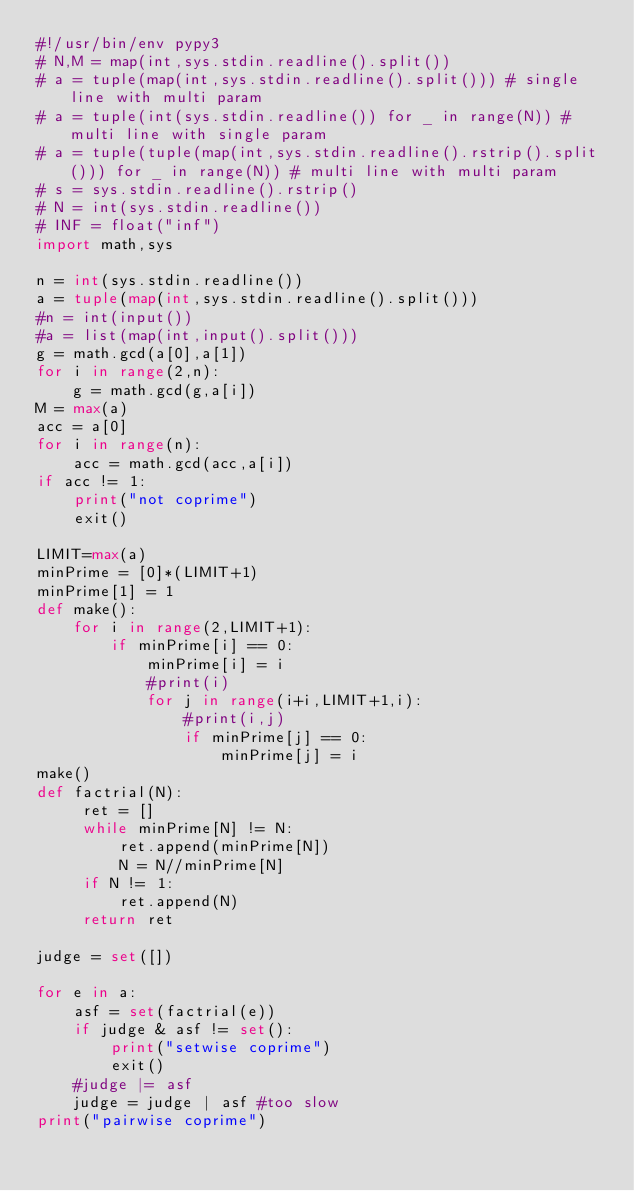<code> <loc_0><loc_0><loc_500><loc_500><_Python_>#!/usr/bin/env pypy3
# N,M = map(int,sys.stdin.readline().split())
# a = tuple(map(int,sys.stdin.readline().split())) # single line with multi param
# a = tuple(int(sys.stdin.readline()) for _ in range(N)) # multi line with single param
# a = tuple(tuple(map(int,sys.stdin.readline().rstrip().split())) for _ in range(N)) # multi line with multi param
# s = sys.stdin.readline().rstrip()
# N = int(sys.stdin.readline())
# INF = float("inf")
import math,sys

n = int(sys.stdin.readline())
a = tuple(map(int,sys.stdin.readline().split()))
#n = int(input())
#a = list(map(int,input().split()))
g = math.gcd(a[0],a[1])
for i in range(2,n):
    g = math.gcd(g,a[i])
M = max(a)
acc = a[0]
for i in range(n):
    acc = math.gcd(acc,a[i])
if acc != 1:
    print("not coprime")
    exit()

LIMIT=max(a)
minPrime = [0]*(LIMIT+1)
minPrime[1] = 1
def make():
    for i in range(2,LIMIT+1):
        if minPrime[i] == 0:
            minPrime[i] = i
            #print(i)
            for j in range(i+i,LIMIT+1,i):
                #print(i,j)
                if minPrime[j] == 0:
                    minPrime[j] = i
make()
def factrial(N):
     ret = []
     while minPrime[N] != N:
         ret.append(minPrime[N])
         N = N//minPrime[N]
     if N != 1:
         ret.append(N)
     return ret

judge = set([])

for e in a:
    asf = set(factrial(e))
    if judge & asf != set():
        print("setwise coprime")
        exit()
    #judge |= asf
    judge = judge | asf #too slow
print("pairwise coprime")</code> 